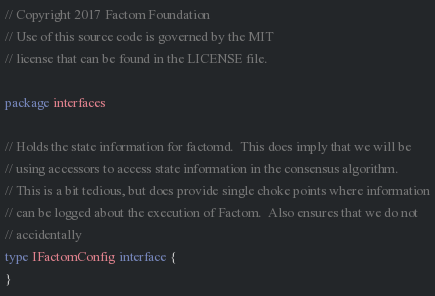Convert code to text. <code><loc_0><loc_0><loc_500><loc_500><_Go_>// Copyright 2017 Factom Foundation
// Use of this source code is governed by the MIT
// license that can be found in the LICENSE file.

package interfaces

// Holds the state information for factomd.  This does imply that we will be
// using accessors to access state information in the consensus algorithm.
// This is a bit tedious, but does provide single choke points where information
// can be logged about the execution of Factom.  Also ensures that we do not
// accidentally
type IFactomConfig interface {
}
</code> 